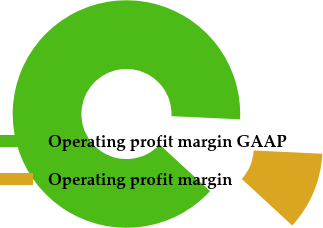Convert chart. <chart><loc_0><loc_0><loc_500><loc_500><pie_chart><fcel>Operating profit margin GAAP<fcel>Operating profit margin<nl><fcel>88.89%<fcel>11.11%<nl></chart> 